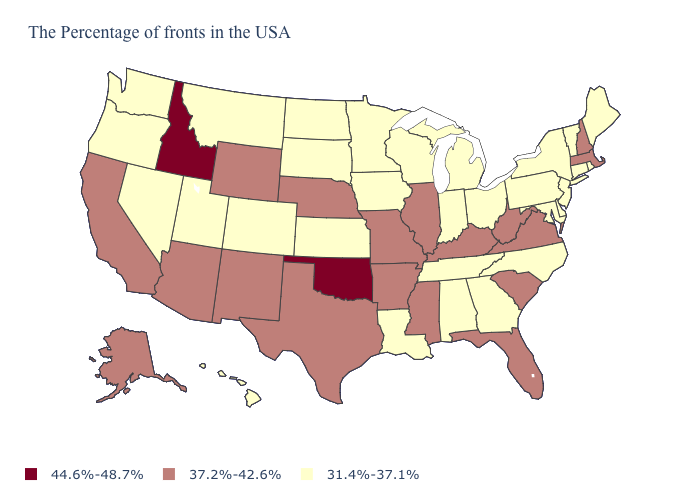Does California have a higher value than Arizona?
Quick response, please. No. What is the lowest value in the USA?
Concise answer only. 31.4%-37.1%. What is the value of Massachusetts?
Answer briefly. 37.2%-42.6%. What is the highest value in the USA?
Keep it brief. 44.6%-48.7%. What is the value of Minnesota?
Be succinct. 31.4%-37.1%. Which states have the lowest value in the USA?
Quick response, please. Maine, Rhode Island, Vermont, Connecticut, New York, New Jersey, Delaware, Maryland, Pennsylvania, North Carolina, Ohio, Georgia, Michigan, Indiana, Alabama, Tennessee, Wisconsin, Louisiana, Minnesota, Iowa, Kansas, South Dakota, North Dakota, Colorado, Utah, Montana, Nevada, Washington, Oregon, Hawaii. Does the first symbol in the legend represent the smallest category?
Be succinct. No. What is the lowest value in the South?
Short answer required. 31.4%-37.1%. Name the states that have a value in the range 37.2%-42.6%?
Quick response, please. Massachusetts, New Hampshire, Virginia, South Carolina, West Virginia, Florida, Kentucky, Illinois, Mississippi, Missouri, Arkansas, Nebraska, Texas, Wyoming, New Mexico, Arizona, California, Alaska. Name the states that have a value in the range 44.6%-48.7%?
Be succinct. Oklahoma, Idaho. What is the value of Ohio?
Quick response, please. 31.4%-37.1%. Which states hav the highest value in the West?
Quick response, please. Idaho. Name the states that have a value in the range 37.2%-42.6%?
Quick response, please. Massachusetts, New Hampshire, Virginia, South Carolina, West Virginia, Florida, Kentucky, Illinois, Mississippi, Missouri, Arkansas, Nebraska, Texas, Wyoming, New Mexico, Arizona, California, Alaska. What is the value of Alaska?
Give a very brief answer. 37.2%-42.6%. Does Washington have the lowest value in the West?
Answer briefly. Yes. 